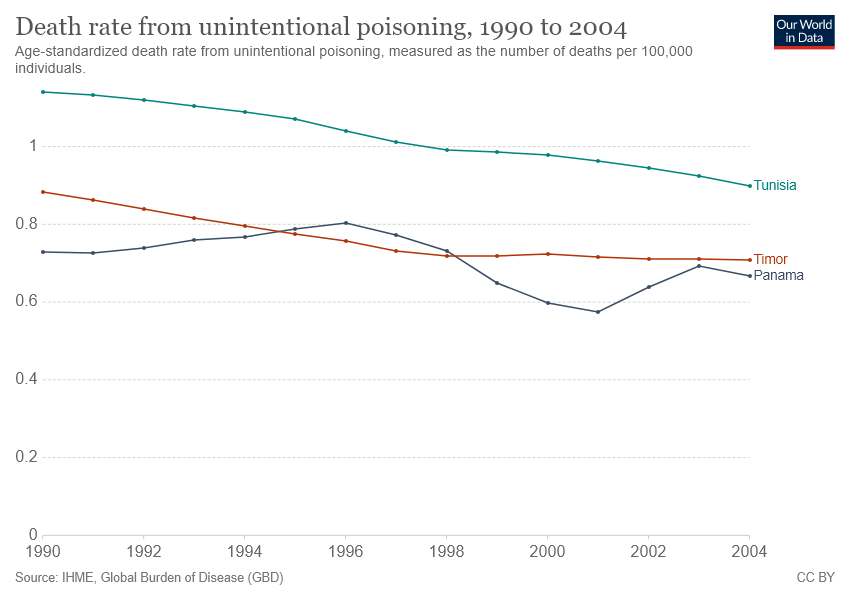Draw attention to some important aspects in this diagram. The death rate from unintentional poisoning is greater in Panama than in Timor for a period of 4 years. In the context of comparing countries based on their graphs, it can be asserted that the Tunisia graph is always greater than others. 